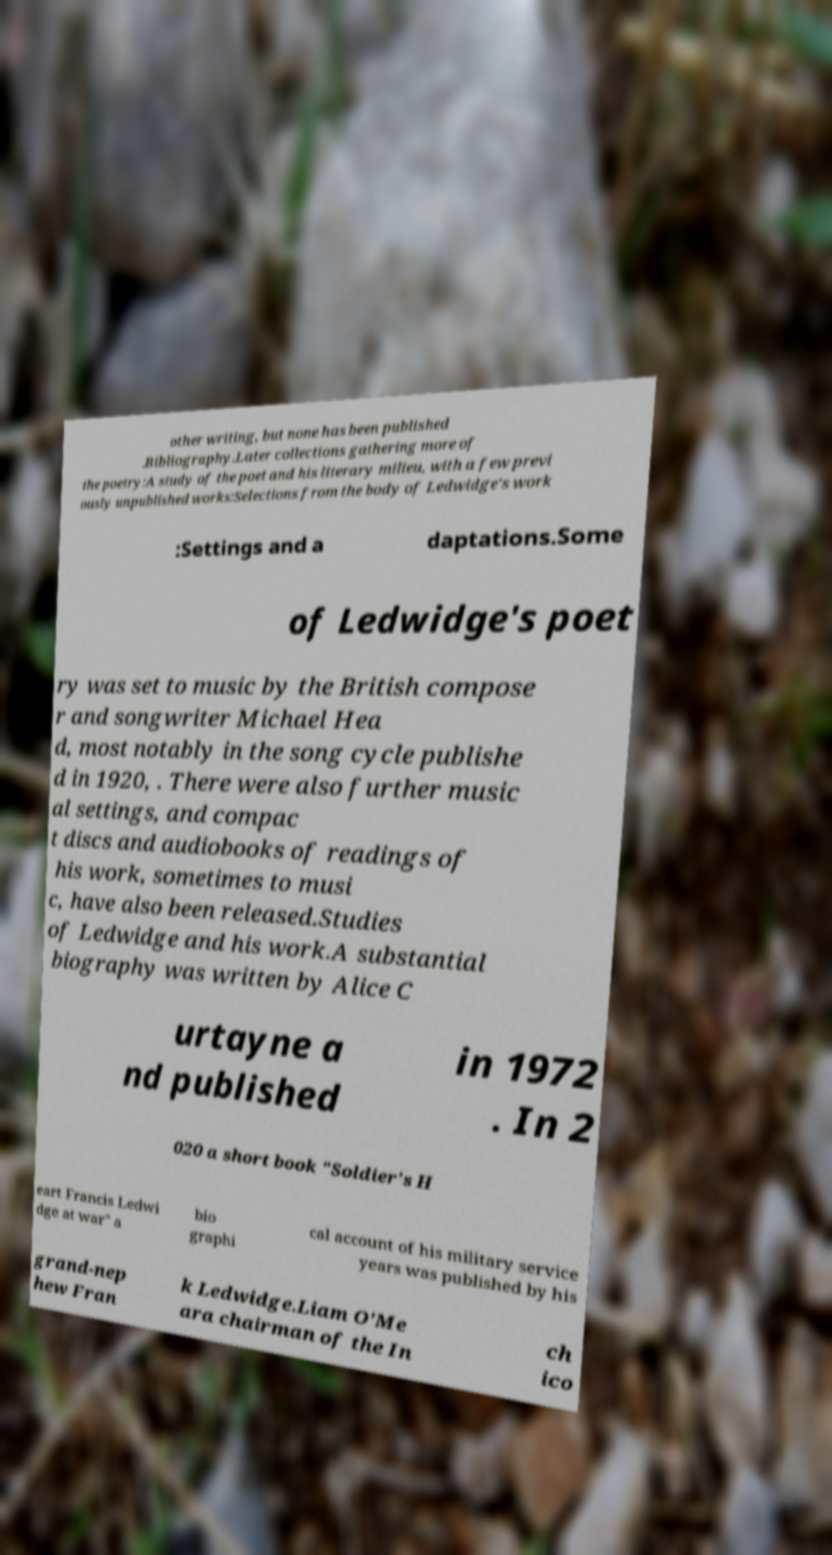Could you assist in decoding the text presented in this image and type it out clearly? other writing, but none has been published .Bibliography.Later collections gathering more of the poetry:A study of the poet and his literary milieu, with a few previ ously unpublished works:Selections from the body of Ledwidge's work :Settings and a daptations.Some of Ledwidge's poet ry was set to music by the British compose r and songwriter Michael Hea d, most notably in the song cycle publishe d in 1920, . There were also further music al settings, and compac t discs and audiobooks of readings of his work, sometimes to musi c, have also been released.Studies of Ledwidge and his work.A substantial biography was written by Alice C urtayne a nd published in 1972 . In 2 020 a short book "Soldier's H eart Francis Ledwi dge at war" a bio graphi cal account of his military service years was published by his grand-nep hew Fran k Ledwidge.Liam O'Me ara chairman of the In ch ico 